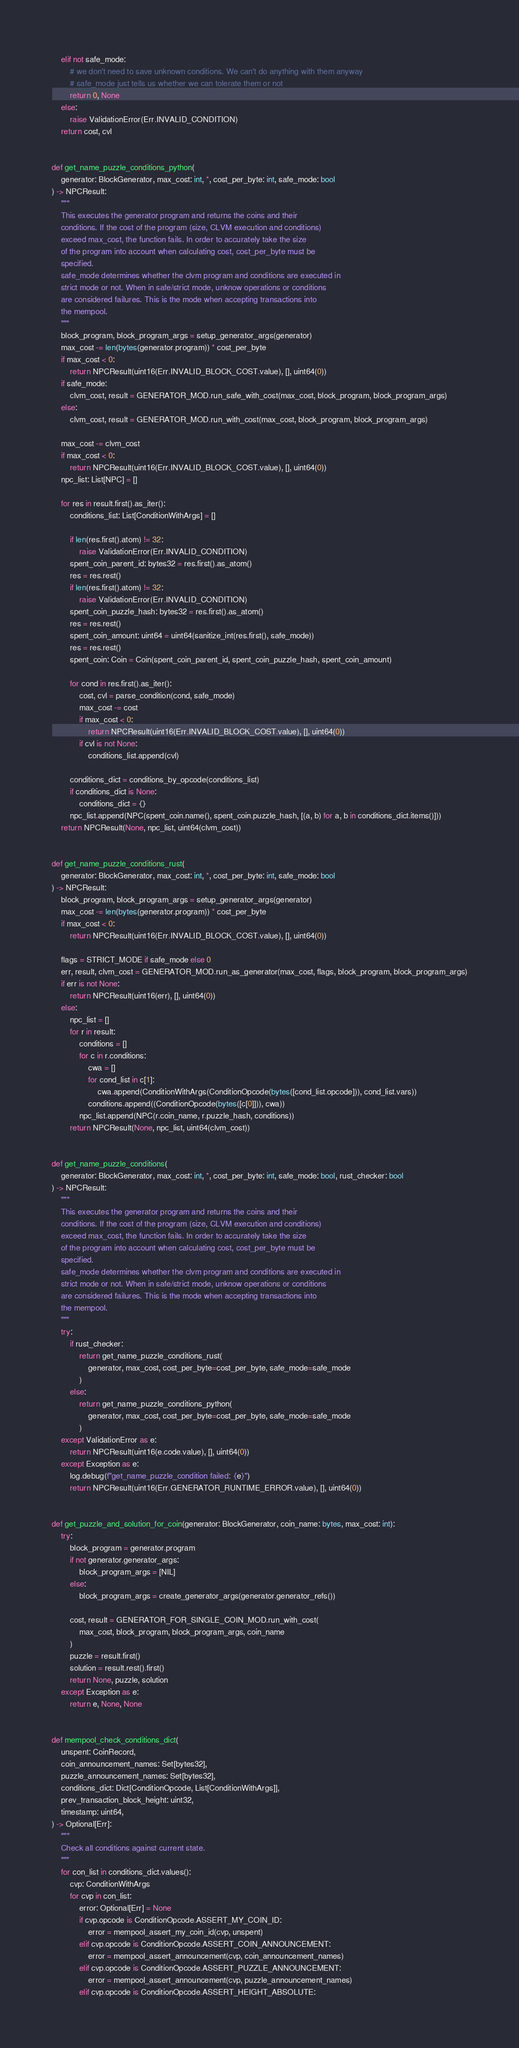<code> <loc_0><loc_0><loc_500><loc_500><_Python_>    elif not safe_mode:
        # we don't need to save unknown conditions. We can't do anything with them anyway
        # safe_mode just tells us whether we can tolerate them or not
        return 0, None
    else:
        raise ValidationError(Err.INVALID_CONDITION)
    return cost, cvl


def get_name_puzzle_conditions_python(
    generator: BlockGenerator, max_cost: int, *, cost_per_byte: int, safe_mode: bool
) -> NPCResult:
    """
    This executes the generator program and returns the coins and their
    conditions. If the cost of the program (size, CLVM execution and conditions)
    exceed max_cost, the function fails. In order to accurately take the size
    of the program into account when calculating cost, cost_per_byte must be
    specified.
    safe_mode determines whether the clvm program and conditions are executed in
    strict mode or not. When in safe/strict mode, unknow operations or conditions
    are considered failures. This is the mode when accepting transactions into
    the mempool.
    """
    block_program, block_program_args = setup_generator_args(generator)
    max_cost -= len(bytes(generator.program)) * cost_per_byte
    if max_cost < 0:
        return NPCResult(uint16(Err.INVALID_BLOCK_COST.value), [], uint64(0))
    if safe_mode:
        clvm_cost, result = GENERATOR_MOD.run_safe_with_cost(max_cost, block_program, block_program_args)
    else:
        clvm_cost, result = GENERATOR_MOD.run_with_cost(max_cost, block_program, block_program_args)

    max_cost -= clvm_cost
    if max_cost < 0:
        return NPCResult(uint16(Err.INVALID_BLOCK_COST.value), [], uint64(0))
    npc_list: List[NPC] = []

    for res in result.first().as_iter():
        conditions_list: List[ConditionWithArgs] = []

        if len(res.first().atom) != 32:
            raise ValidationError(Err.INVALID_CONDITION)
        spent_coin_parent_id: bytes32 = res.first().as_atom()
        res = res.rest()
        if len(res.first().atom) != 32:
            raise ValidationError(Err.INVALID_CONDITION)
        spent_coin_puzzle_hash: bytes32 = res.first().as_atom()
        res = res.rest()
        spent_coin_amount: uint64 = uint64(sanitize_int(res.first(), safe_mode))
        res = res.rest()
        spent_coin: Coin = Coin(spent_coin_parent_id, spent_coin_puzzle_hash, spent_coin_amount)

        for cond in res.first().as_iter():
            cost, cvl = parse_condition(cond, safe_mode)
            max_cost -= cost
            if max_cost < 0:
                return NPCResult(uint16(Err.INVALID_BLOCK_COST.value), [], uint64(0))
            if cvl is not None:
                conditions_list.append(cvl)

        conditions_dict = conditions_by_opcode(conditions_list)
        if conditions_dict is None:
            conditions_dict = {}
        npc_list.append(NPC(spent_coin.name(), spent_coin.puzzle_hash, [(a, b) for a, b in conditions_dict.items()]))
    return NPCResult(None, npc_list, uint64(clvm_cost))


def get_name_puzzle_conditions_rust(
    generator: BlockGenerator, max_cost: int, *, cost_per_byte: int, safe_mode: bool
) -> NPCResult:
    block_program, block_program_args = setup_generator_args(generator)
    max_cost -= len(bytes(generator.program)) * cost_per_byte
    if max_cost < 0:
        return NPCResult(uint16(Err.INVALID_BLOCK_COST.value), [], uint64(0))

    flags = STRICT_MODE if safe_mode else 0
    err, result, clvm_cost = GENERATOR_MOD.run_as_generator(max_cost, flags, block_program, block_program_args)
    if err is not None:
        return NPCResult(uint16(err), [], uint64(0))
    else:
        npc_list = []
        for r in result:
            conditions = []
            for c in r.conditions:
                cwa = []
                for cond_list in c[1]:
                    cwa.append(ConditionWithArgs(ConditionOpcode(bytes([cond_list.opcode])), cond_list.vars))
                conditions.append((ConditionOpcode(bytes([c[0]])), cwa))
            npc_list.append(NPC(r.coin_name, r.puzzle_hash, conditions))
        return NPCResult(None, npc_list, uint64(clvm_cost))


def get_name_puzzle_conditions(
    generator: BlockGenerator, max_cost: int, *, cost_per_byte: int, safe_mode: bool, rust_checker: bool
) -> NPCResult:
    """
    This executes the generator program and returns the coins and their
    conditions. If the cost of the program (size, CLVM execution and conditions)
    exceed max_cost, the function fails. In order to accurately take the size
    of the program into account when calculating cost, cost_per_byte must be
    specified.
    safe_mode determines whether the clvm program and conditions are executed in
    strict mode or not. When in safe/strict mode, unknow operations or conditions
    are considered failures. This is the mode when accepting transactions into
    the mempool.
    """
    try:
        if rust_checker:
            return get_name_puzzle_conditions_rust(
                generator, max_cost, cost_per_byte=cost_per_byte, safe_mode=safe_mode
            )
        else:
            return get_name_puzzle_conditions_python(
                generator, max_cost, cost_per_byte=cost_per_byte, safe_mode=safe_mode
            )
    except ValidationError as e:
        return NPCResult(uint16(e.code.value), [], uint64(0))
    except Exception as e:
        log.debug(f"get_name_puzzle_condition failed: {e}")
        return NPCResult(uint16(Err.GENERATOR_RUNTIME_ERROR.value), [], uint64(0))


def get_puzzle_and_solution_for_coin(generator: BlockGenerator, coin_name: bytes, max_cost: int):
    try:
        block_program = generator.program
        if not generator.generator_args:
            block_program_args = [NIL]
        else:
            block_program_args = create_generator_args(generator.generator_refs())

        cost, result = GENERATOR_FOR_SINGLE_COIN_MOD.run_with_cost(
            max_cost, block_program, block_program_args, coin_name
        )
        puzzle = result.first()
        solution = result.rest().first()
        return None, puzzle, solution
    except Exception as e:
        return e, None, None


def mempool_check_conditions_dict(
    unspent: CoinRecord,
    coin_announcement_names: Set[bytes32],
    puzzle_announcement_names: Set[bytes32],
    conditions_dict: Dict[ConditionOpcode, List[ConditionWithArgs]],
    prev_transaction_block_height: uint32,
    timestamp: uint64,
) -> Optional[Err]:
    """
    Check all conditions against current state.
    """
    for con_list in conditions_dict.values():
        cvp: ConditionWithArgs
        for cvp in con_list:
            error: Optional[Err] = None
            if cvp.opcode is ConditionOpcode.ASSERT_MY_COIN_ID:
                error = mempool_assert_my_coin_id(cvp, unspent)
            elif cvp.opcode is ConditionOpcode.ASSERT_COIN_ANNOUNCEMENT:
                error = mempool_assert_announcement(cvp, coin_announcement_names)
            elif cvp.opcode is ConditionOpcode.ASSERT_PUZZLE_ANNOUNCEMENT:
                error = mempool_assert_announcement(cvp, puzzle_announcement_names)
            elif cvp.opcode is ConditionOpcode.ASSERT_HEIGHT_ABSOLUTE:</code> 